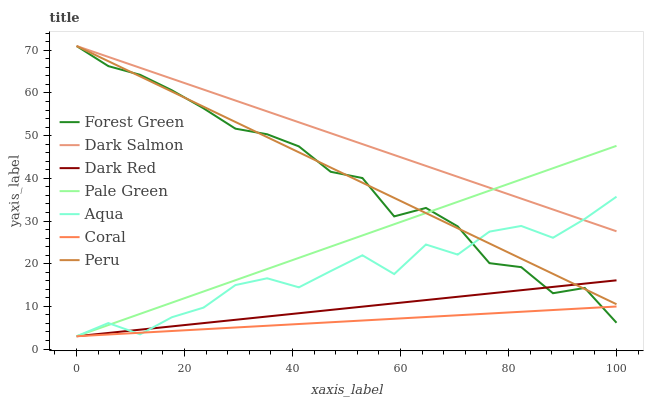Does Coral have the minimum area under the curve?
Answer yes or no. Yes. Does Dark Salmon have the maximum area under the curve?
Answer yes or no. Yes. Does Aqua have the minimum area under the curve?
Answer yes or no. No. Does Aqua have the maximum area under the curve?
Answer yes or no. No. Is Coral the smoothest?
Answer yes or no. Yes. Is Aqua the roughest?
Answer yes or no. Yes. Is Aqua the smoothest?
Answer yes or no. No. Is Coral the roughest?
Answer yes or no. No. Does Dark Salmon have the lowest value?
Answer yes or no. No. Does Aqua have the highest value?
Answer yes or no. No. Is Dark Red less than Dark Salmon?
Answer yes or no. Yes. Is Dark Salmon greater than Coral?
Answer yes or no. Yes. Does Dark Red intersect Dark Salmon?
Answer yes or no. No. 